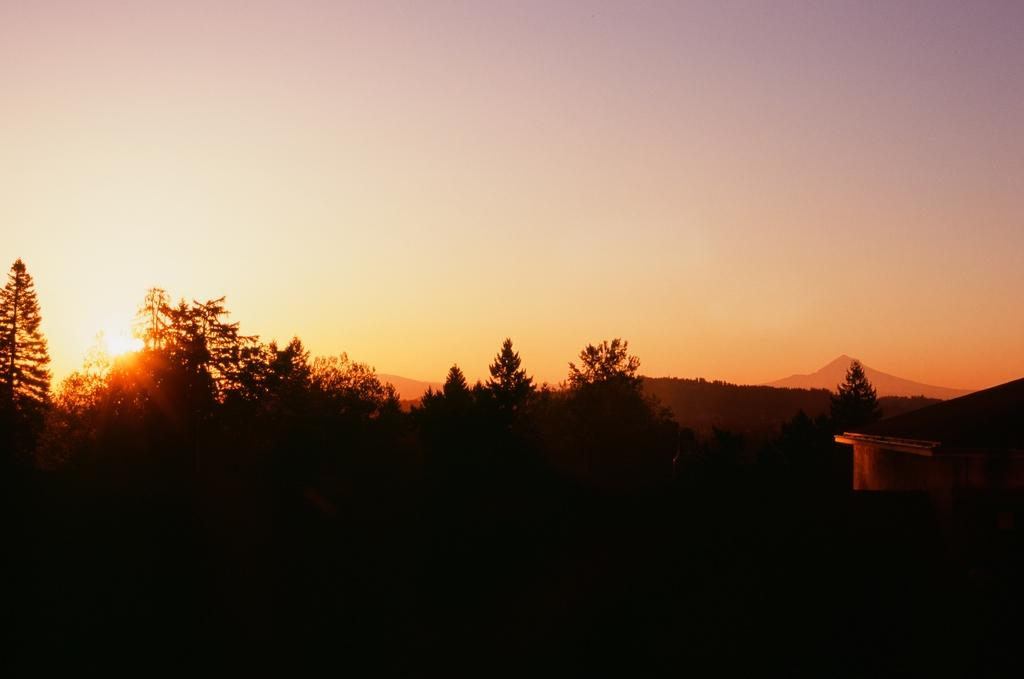What type of vegetation can be seen in the image? There are trees in the image. Where are the trees located in relation to the image? The trees are in the foreground. What is visible in the background of the image? The sky is visible in the image. Can you describe the celestial body visible in the sky? The sun is visible in the image. How would you describe the lighting in the image? The image appears to be a bit dark. What type of joke is being told by the fairies in the image? There are no fairies present in the image, and therefore no jokes can be observed. 